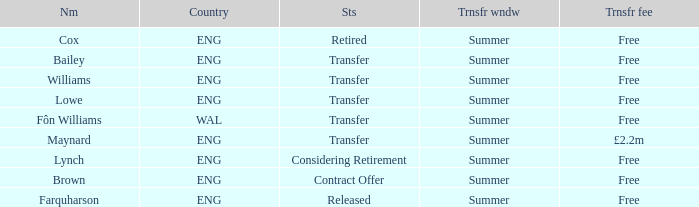What is the status of the Eng Country from the Maynard name? Transfer. 